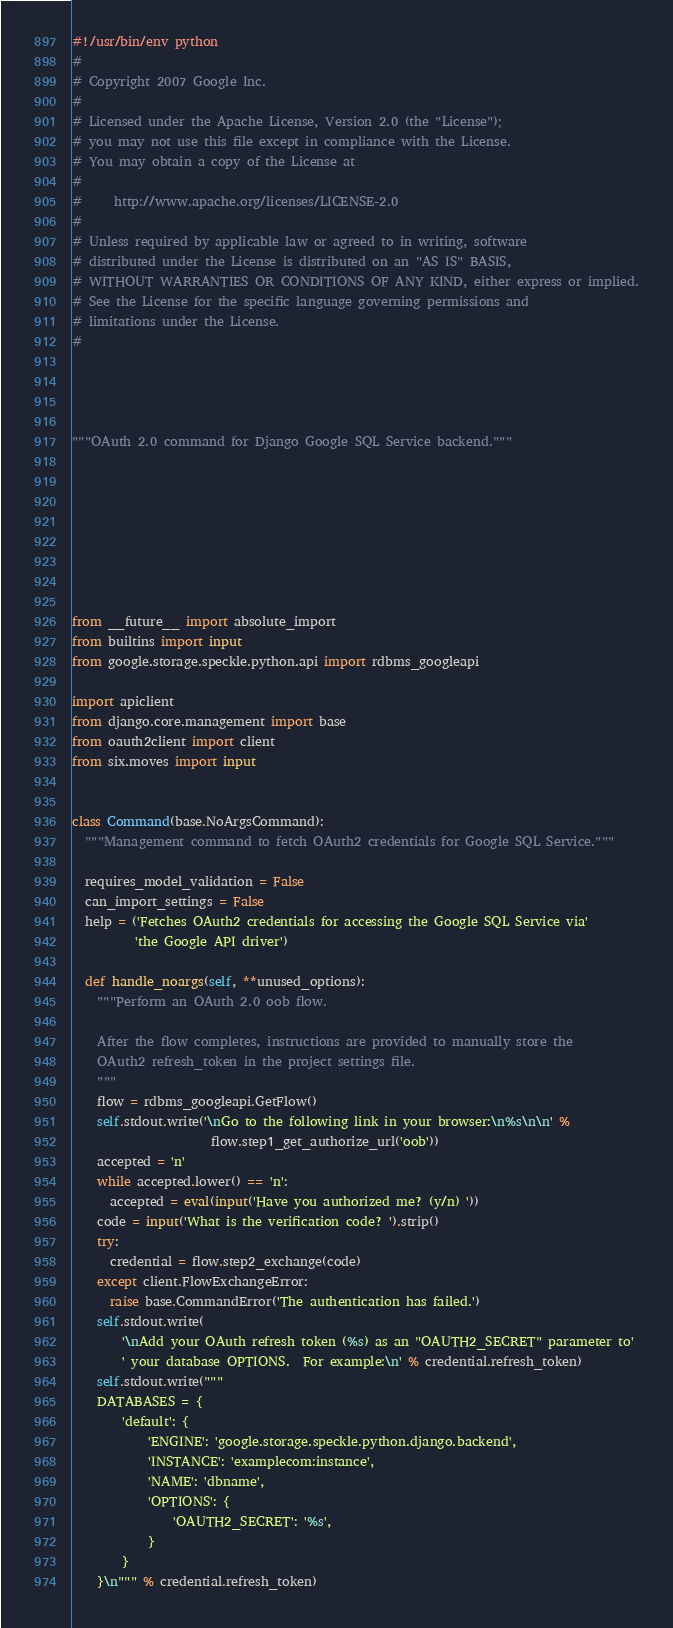Convert code to text. <code><loc_0><loc_0><loc_500><loc_500><_Python_>#!/usr/bin/env python
#
# Copyright 2007 Google Inc.
#
# Licensed under the Apache License, Version 2.0 (the "License");
# you may not use this file except in compliance with the License.
# You may obtain a copy of the License at
#
#     http://www.apache.org/licenses/LICENSE-2.0
#
# Unless required by applicable law or agreed to in writing, software
# distributed under the License is distributed on an "AS IS" BASIS,
# WITHOUT WARRANTIES OR CONDITIONS OF ANY KIND, either express or implied.
# See the License for the specific language governing permissions and
# limitations under the License.
#




"""OAuth 2.0 command for Django Google SQL Service backend."""








from __future__ import absolute_import
from builtins import input
from google.storage.speckle.python.api import rdbms_googleapi

import apiclient
from django.core.management import base
from oauth2client import client
from six.moves import input


class Command(base.NoArgsCommand):
  """Management command to fetch OAuth2 credentials for Google SQL Service."""

  requires_model_validation = False
  can_import_settings = False
  help = ('Fetches OAuth2 credentials for accessing the Google SQL Service via'
          'the Google API driver')

  def handle_noargs(self, **unused_options):
    """Perform an OAuth 2.0 oob flow.

    After the flow completes, instructions are provided to manually store the
    OAuth2 refresh_token in the project settings file.
    """
    flow = rdbms_googleapi.GetFlow()
    self.stdout.write('\nGo to the following link in your browser:\n%s\n\n' %
                      flow.step1_get_authorize_url('oob'))
    accepted = 'n'
    while accepted.lower() == 'n':
      accepted = eval(input('Have you authorized me? (y/n) '))
    code = input('What is the verification code? ').strip()
    try:
      credential = flow.step2_exchange(code)
    except client.FlowExchangeError:
      raise base.CommandError('The authentication has failed.')
    self.stdout.write(
        '\nAdd your OAuth refresh token (%s) as an "OAUTH2_SECRET" parameter to'
        ' your database OPTIONS.  For example:\n' % credential.refresh_token)
    self.stdout.write("""
    DATABASES = {
        'default': {
            'ENGINE': 'google.storage.speckle.python.django.backend',
            'INSTANCE': 'examplecom:instance',
            'NAME': 'dbname',
            'OPTIONS': {
                'OAUTH2_SECRET': '%s',
            }
        }
    }\n""" % credential.refresh_token)

</code> 